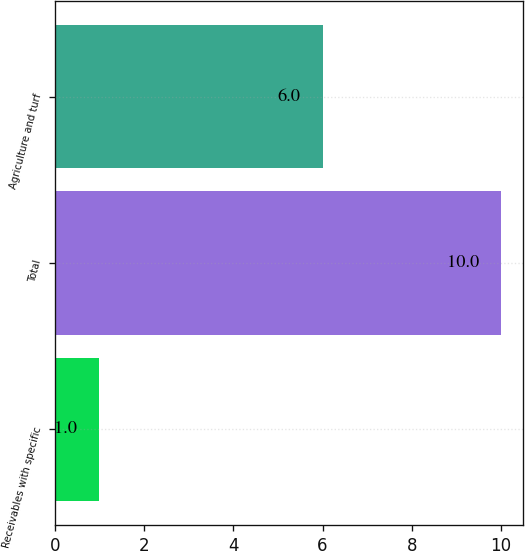Convert chart. <chart><loc_0><loc_0><loc_500><loc_500><bar_chart><fcel>Receivables with specific<fcel>Total<fcel>Agriculture and turf<nl><fcel>1<fcel>10<fcel>6<nl></chart> 